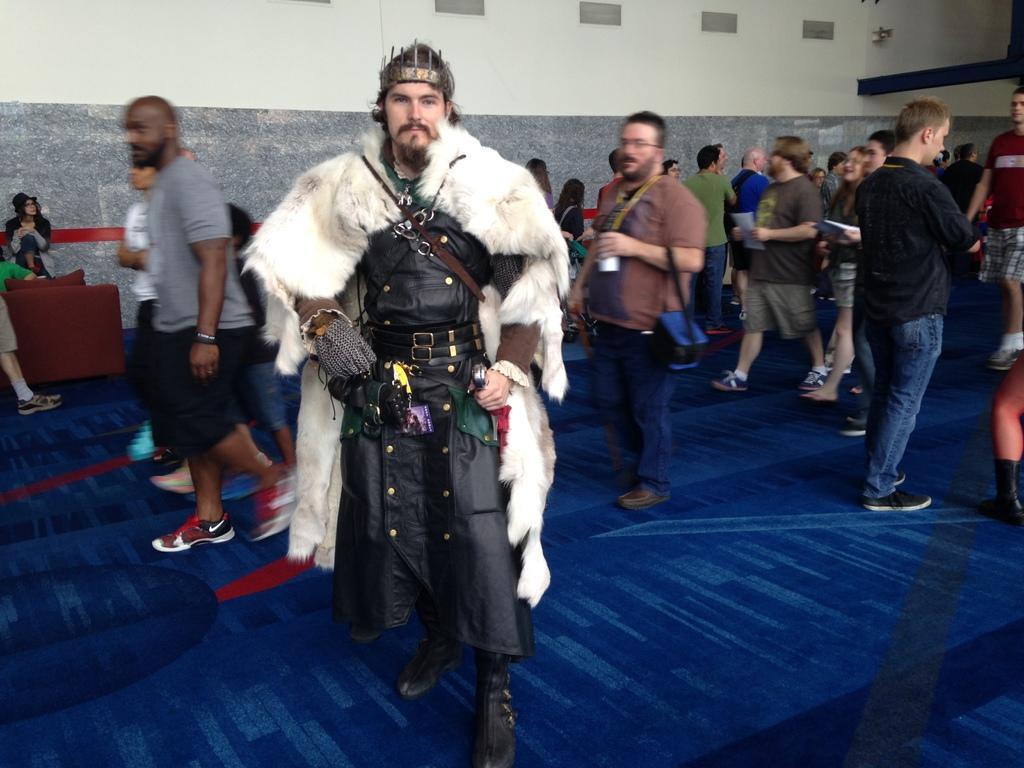Could you give a brief overview of what you see in this image? In this picture we can see a man wearing black and white costume, standing in the front and giving a pose to the camera. Behind we can see some people walking in the hall. In the background there is a white wall. 